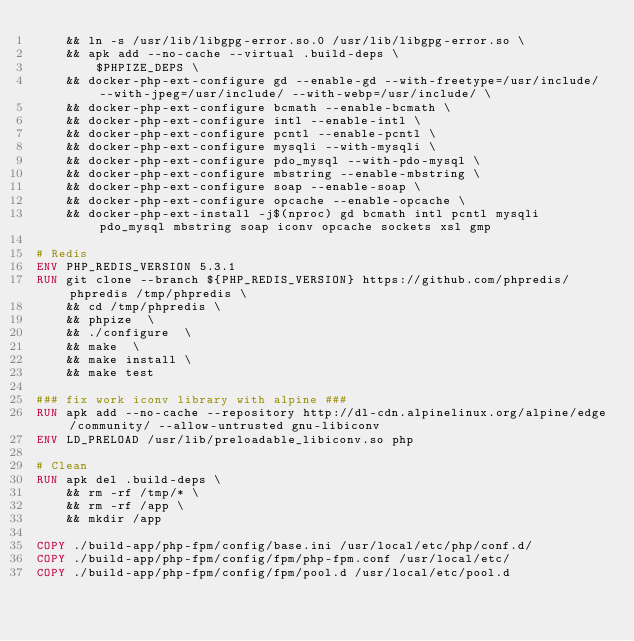Convert code to text. <code><loc_0><loc_0><loc_500><loc_500><_Dockerfile_>    && ln -s /usr/lib/libgpg-error.so.0 /usr/lib/libgpg-error.so \
    && apk add --no-cache --virtual .build-deps \
        $PHPIZE_DEPS \
    && docker-php-ext-configure gd --enable-gd --with-freetype=/usr/include/ --with-jpeg=/usr/include/ --with-webp=/usr/include/ \
    && docker-php-ext-configure bcmath --enable-bcmath \
    && docker-php-ext-configure intl --enable-intl \
    && docker-php-ext-configure pcntl --enable-pcntl \
    && docker-php-ext-configure mysqli --with-mysqli \
    && docker-php-ext-configure pdo_mysql --with-pdo-mysql \
    && docker-php-ext-configure mbstring --enable-mbstring \
    && docker-php-ext-configure soap --enable-soap \
    && docker-php-ext-configure opcache --enable-opcache \
    && docker-php-ext-install -j$(nproc) gd bcmath intl pcntl mysqli pdo_mysql mbstring soap iconv opcache sockets xsl gmp

# Redis
ENV PHP_REDIS_VERSION 5.3.1
RUN git clone --branch ${PHP_REDIS_VERSION} https://github.com/phpredis/phpredis /tmp/phpredis \
    && cd /tmp/phpredis \
    && phpize  \
    && ./configure  \
    && make  \
    && make install \
    && make test

### fix work iconv library with alpine ###
RUN apk add --no-cache --repository http://dl-cdn.alpinelinux.org/alpine/edge/community/ --allow-untrusted gnu-libiconv
ENV LD_PRELOAD /usr/lib/preloadable_libiconv.so php

# Clean
RUN apk del .build-deps \
    && rm -rf /tmp/* \
    && rm -rf /app \
    && mkdir /app

COPY ./build-app/php-fpm/config/base.ini /usr/local/etc/php/conf.d/
COPY ./build-app/php-fpm/config/fpm/php-fpm.conf /usr/local/etc/
COPY ./build-app/php-fpm/config/fpm/pool.d /usr/local/etc/pool.d
</code> 